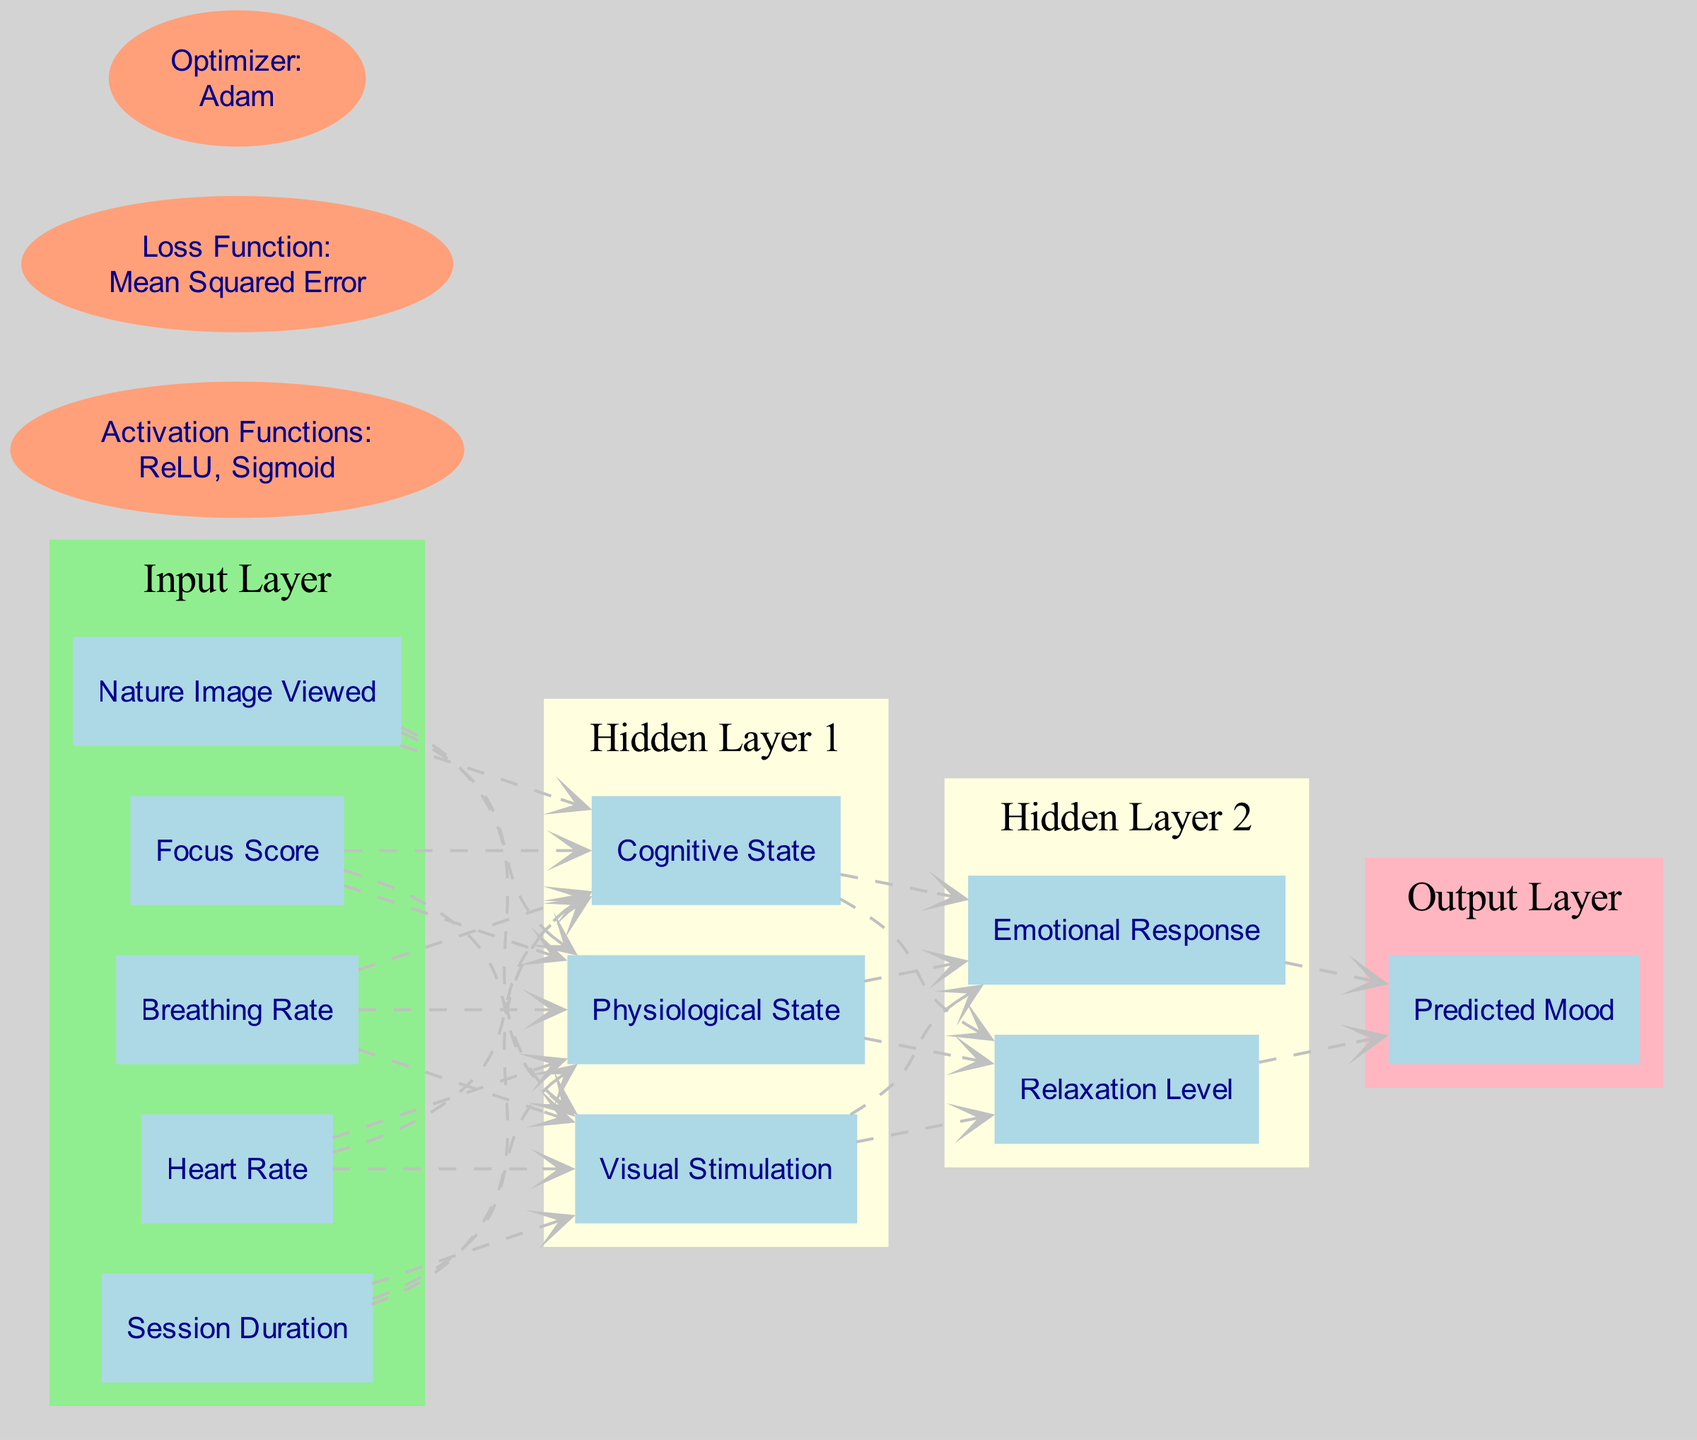What are the nodes in the input layer? The input layer consists of five nodes representing different features, specifically 'Session Duration', 'Heart Rate', 'Breathing Rate', 'Focus Score', and 'Nature Image Viewed'.
Answer: Session Duration, Heart Rate, Breathing Rate, Focus Score, Nature Image Viewed How many nodes are in the second hidden layer? The second hidden layer contains two nodes, which are 'Relaxation Level' and 'Emotional Response'. This can be confirmed by counting the nodes listed in that layer.
Answer: 2 What is the activation function used after the hidden layers? The activation functions used in this architecture include 'ReLU' and 'Sigmoid'. This is indicated by the specific mention of activation functions in the diagram.
Answer: ReLU, Sigmoid Which layer directly outputs the predicted mood? The output layer has one node, 'Predicted Mood', which indicates that this is the final output of the neural network structure shown in the diagram.
Answer: Predicted Mood What is the loss function utilized in this diagram? The diagram specifies 'Mean Squared Error' as the loss function employed, which is typically used for regression tasks and indicates how well the model's predictions match the actual data.
Answer: Mean Squared Error How does the first hidden layer connect to the second hidden layer? The connection is established through the nodes in the first hidden layer ('Physiological State', 'Cognitive State', 'Visual Stimulation'), which all connect to the nodes in the second hidden layer, thus allowing information to flow from one layer to the next.
Answer: Through all nodes in the first hidden layer What is the relationship between 'Nature Image Viewed' and 'Predicted Mood'? The 'Nature Image Viewed' is an input feature affecting the prediction in the output layer, specifically contributing to the 'Predicted Mood'. The flow of connections from the input layer to the output layer demonstrates this relation.
Answer: Input affects output What type of neural network is represented in this diagram? This diagram illustrates a feedforward neural network architecture, where information moves in one direction from the input layer through hidden layers to the output layer without looping back.
Answer: Feedforward neural network What optimizer is used in the diagram? The diagram specifies 'Adam' as the optimizer utilized to update the weights of the network during training, which is popular for its efficiency and ability to handle sparse gradients.
Answer: Adam 